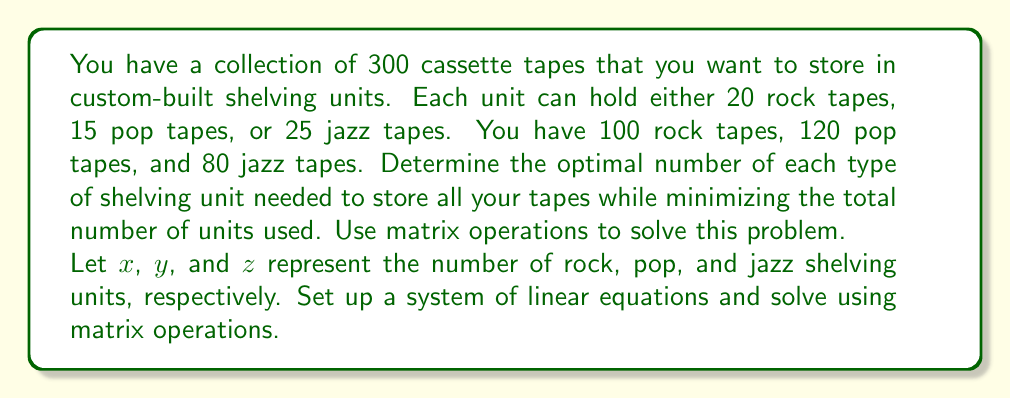Could you help me with this problem? Let's approach this step-by-step:

1) First, we set up a system of linear equations:

   $$20x + 0y + 0z = 100$$ (rock tapes)
   $$0x + 15y + 0z = 120$$ (pop tapes)
   $$0x + 0y + 25z = 80$$ (jazz tapes)

2) We can represent this system as a matrix equation $AX = B$:

   $$\begin{bmatrix}
   20 & 0 & 0 \\
   0 & 15 & 0 \\
   0 & 0 & 25
   \end{bmatrix}
   \begin{bmatrix}
   x \\
   y \\
   z
   \end{bmatrix} =
   \begin{bmatrix}
   100 \\
   120 \\
   80
   \end{bmatrix}$$

3) To solve for $X$, we multiply both sides by $A^{-1}$:

   $$A^{-1}AX = A^{-1}B$$
   $$X = A^{-1}B$$

4) Calculate $A^{-1}$:

   $$A^{-1} = \begin{bmatrix}
   1/20 & 0 & 0 \\
   0 & 1/15 & 0 \\
   0 & 0 & 1/25
   \end{bmatrix}$$

5) Now we can solve for $X$:

   $$X = A^{-1}B = 
   \begin{bmatrix}
   1/20 & 0 & 0 \\
   0 & 1/15 & 0 \\
   0 & 0 & 1/25
   \end{bmatrix}
   \begin{bmatrix}
   100 \\
   120 \\
   80
   \end{bmatrix} =
   \begin{bmatrix}
   5 \\
   8 \\
   3.2
   \end{bmatrix}$$

6) Since we can't have fractional shelving units, we need to round up to the nearest whole number:

   $x = 5$ (rock units)
   $y = 8$ (pop units)
   $z = 4$ (jazz units)

Therefore, the optimal configuration is 5 rock units, 8 pop units, and 4 jazz units, for a total of 17 shelving units.
Answer: The optimal storage configuration requires 5 rock shelving units, 8 pop shelving units, and 4 jazz shelving units, for a total of 17 units. 